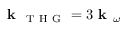<formula> <loc_0><loc_0><loc_500><loc_500>k _ { T H G } = 3 k _ { \omega }</formula> 